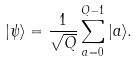Convert formula to latex. <formula><loc_0><loc_0><loc_500><loc_500>| \psi \rangle = \frac { 1 } { \sqrt { Q } } \sum _ { a = 0 } ^ { Q - 1 } | a \rangle .</formula> 